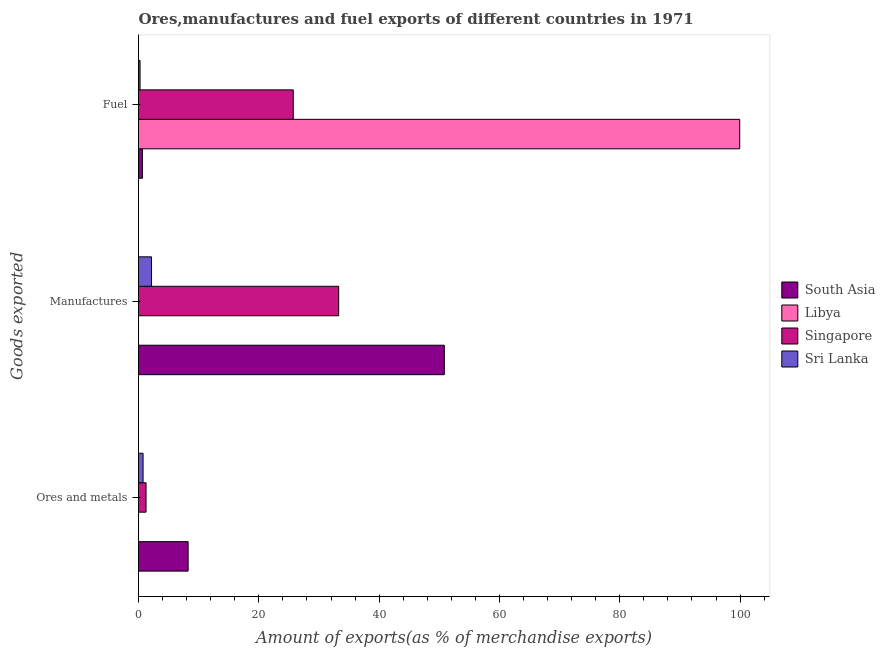What is the label of the 3rd group of bars from the top?
Ensure brevity in your answer.  Ores and metals. What is the percentage of fuel exports in Sri Lanka?
Offer a very short reply. 0.26. Across all countries, what is the maximum percentage of manufactures exports?
Offer a terse response. 50.84. Across all countries, what is the minimum percentage of manufactures exports?
Your response must be concise. 7.47831394155619e-6. In which country was the percentage of fuel exports minimum?
Keep it short and to the point. Sri Lanka. What is the total percentage of ores and metals exports in the graph?
Offer a terse response. 10.27. What is the difference between the percentage of manufactures exports in Libya and that in Singapore?
Offer a very short reply. -33.27. What is the difference between the percentage of ores and metals exports in Singapore and the percentage of fuel exports in Sri Lanka?
Give a very brief answer. 1. What is the average percentage of fuel exports per country?
Your answer should be compact. 31.64. What is the difference between the percentage of ores and metals exports and percentage of fuel exports in Libya?
Your response must be concise. -99.94. What is the ratio of the percentage of fuel exports in Singapore to that in South Asia?
Offer a very short reply. 39.73. What is the difference between the highest and the second highest percentage of manufactures exports?
Your response must be concise. 17.56. What is the difference between the highest and the lowest percentage of fuel exports?
Provide a succinct answer. 99.69. In how many countries, is the percentage of fuel exports greater than the average percentage of fuel exports taken over all countries?
Provide a short and direct response. 1. Is the sum of the percentage of ores and metals exports in South Asia and Sri Lanka greater than the maximum percentage of manufactures exports across all countries?
Offer a terse response. No. What does the 1st bar from the top in Fuel represents?
Your answer should be compact. Sri Lanka. Is it the case that in every country, the sum of the percentage of ores and metals exports and percentage of manufactures exports is greater than the percentage of fuel exports?
Provide a short and direct response. No. Are the values on the major ticks of X-axis written in scientific E-notation?
Make the answer very short. No. Does the graph contain grids?
Ensure brevity in your answer.  No. How many legend labels are there?
Your answer should be very brief. 4. How are the legend labels stacked?
Keep it short and to the point. Vertical. What is the title of the graph?
Your answer should be very brief. Ores,manufactures and fuel exports of different countries in 1971. What is the label or title of the X-axis?
Your response must be concise. Amount of exports(as % of merchandise exports). What is the label or title of the Y-axis?
Make the answer very short. Goods exported. What is the Amount of exports(as % of merchandise exports) in South Asia in Ores and metals?
Give a very brief answer. 8.25. What is the Amount of exports(as % of merchandise exports) of Libya in Ores and metals?
Give a very brief answer. 0. What is the Amount of exports(as % of merchandise exports) of Singapore in Ores and metals?
Make the answer very short. 1.25. What is the Amount of exports(as % of merchandise exports) of Sri Lanka in Ores and metals?
Offer a very short reply. 0.76. What is the Amount of exports(as % of merchandise exports) in South Asia in Manufactures?
Offer a very short reply. 50.84. What is the Amount of exports(as % of merchandise exports) of Libya in Manufactures?
Your response must be concise. 7.47831394155619e-6. What is the Amount of exports(as % of merchandise exports) in Singapore in Manufactures?
Provide a succinct answer. 33.27. What is the Amount of exports(as % of merchandise exports) of Sri Lanka in Manufactures?
Provide a succinct answer. 2.16. What is the Amount of exports(as % of merchandise exports) in South Asia in Fuel?
Your answer should be very brief. 0.65. What is the Amount of exports(as % of merchandise exports) in Libya in Fuel?
Provide a succinct answer. 99.95. What is the Amount of exports(as % of merchandise exports) of Singapore in Fuel?
Provide a succinct answer. 25.72. What is the Amount of exports(as % of merchandise exports) in Sri Lanka in Fuel?
Your answer should be very brief. 0.26. Across all Goods exported, what is the maximum Amount of exports(as % of merchandise exports) of South Asia?
Provide a succinct answer. 50.84. Across all Goods exported, what is the maximum Amount of exports(as % of merchandise exports) of Libya?
Your response must be concise. 99.95. Across all Goods exported, what is the maximum Amount of exports(as % of merchandise exports) in Singapore?
Give a very brief answer. 33.27. Across all Goods exported, what is the maximum Amount of exports(as % of merchandise exports) of Sri Lanka?
Make the answer very short. 2.16. Across all Goods exported, what is the minimum Amount of exports(as % of merchandise exports) of South Asia?
Provide a short and direct response. 0.65. Across all Goods exported, what is the minimum Amount of exports(as % of merchandise exports) in Libya?
Ensure brevity in your answer.  7.47831394155619e-6. Across all Goods exported, what is the minimum Amount of exports(as % of merchandise exports) of Singapore?
Make the answer very short. 1.25. Across all Goods exported, what is the minimum Amount of exports(as % of merchandise exports) in Sri Lanka?
Provide a succinct answer. 0.26. What is the total Amount of exports(as % of merchandise exports) in South Asia in the graph?
Offer a very short reply. 59.73. What is the total Amount of exports(as % of merchandise exports) of Libya in the graph?
Your answer should be compact. 99.95. What is the total Amount of exports(as % of merchandise exports) in Singapore in the graph?
Offer a terse response. 60.25. What is the total Amount of exports(as % of merchandise exports) of Sri Lanka in the graph?
Your response must be concise. 3.18. What is the difference between the Amount of exports(as % of merchandise exports) of South Asia in Ores and metals and that in Manufactures?
Make the answer very short. -42.59. What is the difference between the Amount of exports(as % of merchandise exports) of Libya in Ores and metals and that in Manufactures?
Offer a very short reply. 0. What is the difference between the Amount of exports(as % of merchandise exports) in Singapore in Ores and metals and that in Manufactures?
Ensure brevity in your answer.  -32.02. What is the difference between the Amount of exports(as % of merchandise exports) of Sri Lanka in Ores and metals and that in Manufactures?
Make the answer very short. -1.4. What is the difference between the Amount of exports(as % of merchandise exports) of South Asia in Ores and metals and that in Fuel?
Your answer should be very brief. 7.6. What is the difference between the Amount of exports(as % of merchandise exports) of Libya in Ores and metals and that in Fuel?
Make the answer very short. -99.94. What is the difference between the Amount of exports(as % of merchandise exports) of Singapore in Ores and metals and that in Fuel?
Provide a succinct answer. -24.47. What is the difference between the Amount of exports(as % of merchandise exports) of Sri Lanka in Ores and metals and that in Fuel?
Provide a succinct answer. 0.51. What is the difference between the Amount of exports(as % of merchandise exports) of South Asia in Manufactures and that in Fuel?
Make the answer very short. 50.19. What is the difference between the Amount of exports(as % of merchandise exports) in Libya in Manufactures and that in Fuel?
Your answer should be very brief. -99.95. What is the difference between the Amount of exports(as % of merchandise exports) of Singapore in Manufactures and that in Fuel?
Give a very brief answer. 7.55. What is the difference between the Amount of exports(as % of merchandise exports) of Sri Lanka in Manufactures and that in Fuel?
Provide a succinct answer. 1.91. What is the difference between the Amount of exports(as % of merchandise exports) of South Asia in Ores and metals and the Amount of exports(as % of merchandise exports) of Libya in Manufactures?
Offer a very short reply. 8.25. What is the difference between the Amount of exports(as % of merchandise exports) of South Asia in Ores and metals and the Amount of exports(as % of merchandise exports) of Singapore in Manufactures?
Provide a short and direct response. -25.03. What is the difference between the Amount of exports(as % of merchandise exports) of South Asia in Ores and metals and the Amount of exports(as % of merchandise exports) of Sri Lanka in Manufactures?
Ensure brevity in your answer.  6.08. What is the difference between the Amount of exports(as % of merchandise exports) of Libya in Ores and metals and the Amount of exports(as % of merchandise exports) of Singapore in Manufactures?
Your answer should be very brief. -33.27. What is the difference between the Amount of exports(as % of merchandise exports) in Libya in Ores and metals and the Amount of exports(as % of merchandise exports) in Sri Lanka in Manufactures?
Offer a terse response. -2.16. What is the difference between the Amount of exports(as % of merchandise exports) in Singapore in Ores and metals and the Amount of exports(as % of merchandise exports) in Sri Lanka in Manufactures?
Your answer should be compact. -0.91. What is the difference between the Amount of exports(as % of merchandise exports) in South Asia in Ores and metals and the Amount of exports(as % of merchandise exports) in Libya in Fuel?
Provide a short and direct response. -91.7. What is the difference between the Amount of exports(as % of merchandise exports) of South Asia in Ores and metals and the Amount of exports(as % of merchandise exports) of Singapore in Fuel?
Keep it short and to the point. -17.48. What is the difference between the Amount of exports(as % of merchandise exports) in South Asia in Ores and metals and the Amount of exports(as % of merchandise exports) in Sri Lanka in Fuel?
Your response must be concise. 7.99. What is the difference between the Amount of exports(as % of merchandise exports) of Libya in Ores and metals and the Amount of exports(as % of merchandise exports) of Singapore in Fuel?
Provide a short and direct response. -25.72. What is the difference between the Amount of exports(as % of merchandise exports) in Libya in Ores and metals and the Amount of exports(as % of merchandise exports) in Sri Lanka in Fuel?
Make the answer very short. -0.25. What is the difference between the Amount of exports(as % of merchandise exports) in Singapore in Ores and metals and the Amount of exports(as % of merchandise exports) in Sri Lanka in Fuel?
Give a very brief answer. 1. What is the difference between the Amount of exports(as % of merchandise exports) of South Asia in Manufactures and the Amount of exports(as % of merchandise exports) of Libya in Fuel?
Keep it short and to the point. -49.11. What is the difference between the Amount of exports(as % of merchandise exports) of South Asia in Manufactures and the Amount of exports(as % of merchandise exports) of Singapore in Fuel?
Make the answer very short. 25.11. What is the difference between the Amount of exports(as % of merchandise exports) of South Asia in Manufactures and the Amount of exports(as % of merchandise exports) of Sri Lanka in Fuel?
Your answer should be very brief. 50.58. What is the difference between the Amount of exports(as % of merchandise exports) in Libya in Manufactures and the Amount of exports(as % of merchandise exports) in Singapore in Fuel?
Give a very brief answer. -25.72. What is the difference between the Amount of exports(as % of merchandise exports) in Libya in Manufactures and the Amount of exports(as % of merchandise exports) in Sri Lanka in Fuel?
Offer a terse response. -0.26. What is the difference between the Amount of exports(as % of merchandise exports) in Singapore in Manufactures and the Amount of exports(as % of merchandise exports) in Sri Lanka in Fuel?
Your response must be concise. 33.02. What is the average Amount of exports(as % of merchandise exports) of South Asia per Goods exported?
Your answer should be very brief. 19.91. What is the average Amount of exports(as % of merchandise exports) in Libya per Goods exported?
Make the answer very short. 33.32. What is the average Amount of exports(as % of merchandise exports) in Singapore per Goods exported?
Your answer should be very brief. 20.08. What is the average Amount of exports(as % of merchandise exports) in Sri Lanka per Goods exported?
Your answer should be very brief. 1.06. What is the difference between the Amount of exports(as % of merchandise exports) in South Asia and Amount of exports(as % of merchandise exports) in Libya in Ores and metals?
Your answer should be compact. 8.24. What is the difference between the Amount of exports(as % of merchandise exports) of South Asia and Amount of exports(as % of merchandise exports) of Singapore in Ores and metals?
Your answer should be compact. 7. What is the difference between the Amount of exports(as % of merchandise exports) in South Asia and Amount of exports(as % of merchandise exports) in Sri Lanka in Ores and metals?
Your response must be concise. 7.49. What is the difference between the Amount of exports(as % of merchandise exports) in Libya and Amount of exports(as % of merchandise exports) in Singapore in Ores and metals?
Your answer should be very brief. -1.25. What is the difference between the Amount of exports(as % of merchandise exports) in Libya and Amount of exports(as % of merchandise exports) in Sri Lanka in Ores and metals?
Offer a terse response. -0.76. What is the difference between the Amount of exports(as % of merchandise exports) of Singapore and Amount of exports(as % of merchandise exports) of Sri Lanka in Ores and metals?
Your response must be concise. 0.49. What is the difference between the Amount of exports(as % of merchandise exports) in South Asia and Amount of exports(as % of merchandise exports) in Libya in Manufactures?
Your answer should be compact. 50.84. What is the difference between the Amount of exports(as % of merchandise exports) of South Asia and Amount of exports(as % of merchandise exports) of Singapore in Manufactures?
Your response must be concise. 17.56. What is the difference between the Amount of exports(as % of merchandise exports) of South Asia and Amount of exports(as % of merchandise exports) of Sri Lanka in Manufactures?
Keep it short and to the point. 48.67. What is the difference between the Amount of exports(as % of merchandise exports) in Libya and Amount of exports(as % of merchandise exports) in Singapore in Manufactures?
Provide a succinct answer. -33.27. What is the difference between the Amount of exports(as % of merchandise exports) in Libya and Amount of exports(as % of merchandise exports) in Sri Lanka in Manufactures?
Give a very brief answer. -2.16. What is the difference between the Amount of exports(as % of merchandise exports) in Singapore and Amount of exports(as % of merchandise exports) in Sri Lanka in Manufactures?
Offer a very short reply. 31.11. What is the difference between the Amount of exports(as % of merchandise exports) in South Asia and Amount of exports(as % of merchandise exports) in Libya in Fuel?
Keep it short and to the point. -99.3. What is the difference between the Amount of exports(as % of merchandise exports) of South Asia and Amount of exports(as % of merchandise exports) of Singapore in Fuel?
Give a very brief answer. -25.08. What is the difference between the Amount of exports(as % of merchandise exports) in South Asia and Amount of exports(as % of merchandise exports) in Sri Lanka in Fuel?
Provide a succinct answer. 0.39. What is the difference between the Amount of exports(as % of merchandise exports) in Libya and Amount of exports(as % of merchandise exports) in Singapore in Fuel?
Provide a succinct answer. 74.22. What is the difference between the Amount of exports(as % of merchandise exports) of Libya and Amount of exports(as % of merchandise exports) of Sri Lanka in Fuel?
Your response must be concise. 99.69. What is the difference between the Amount of exports(as % of merchandise exports) in Singapore and Amount of exports(as % of merchandise exports) in Sri Lanka in Fuel?
Your answer should be very brief. 25.47. What is the ratio of the Amount of exports(as % of merchandise exports) in South Asia in Ores and metals to that in Manufactures?
Provide a short and direct response. 0.16. What is the ratio of the Amount of exports(as % of merchandise exports) in Libya in Ores and metals to that in Manufactures?
Offer a terse response. 565.87. What is the ratio of the Amount of exports(as % of merchandise exports) of Singapore in Ores and metals to that in Manufactures?
Provide a short and direct response. 0.04. What is the ratio of the Amount of exports(as % of merchandise exports) of Sri Lanka in Ores and metals to that in Manufactures?
Provide a short and direct response. 0.35. What is the ratio of the Amount of exports(as % of merchandise exports) in South Asia in Ores and metals to that in Fuel?
Your answer should be very brief. 12.74. What is the ratio of the Amount of exports(as % of merchandise exports) of Libya in Ores and metals to that in Fuel?
Offer a very short reply. 0. What is the ratio of the Amount of exports(as % of merchandise exports) in Singapore in Ores and metals to that in Fuel?
Provide a short and direct response. 0.05. What is the ratio of the Amount of exports(as % of merchandise exports) of Sri Lanka in Ores and metals to that in Fuel?
Ensure brevity in your answer.  2.98. What is the ratio of the Amount of exports(as % of merchandise exports) in South Asia in Manufactures to that in Fuel?
Your answer should be compact. 78.53. What is the ratio of the Amount of exports(as % of merchandise exports) in Singapore in Manufactures to that in Fuel?
Ensure brevity in your answer.  1.29. What is the ratio of the Amount of exports(as % of merchandise exports) in Sri Lanka in Manufactures to that in Fuel?
Keep it short and to the point. 8.48. What is the difference between the highest and the second highest Amount of exports(as % of merchandise exports) of South Asia?
Give a very brief answer. 42.59. What is the difference between the highest and the second highest Amount of exports(as % of merchandise exports) in Libya?
Keep it short and to the point. 99.94. What is the difference between the highest and the second highest Amount of exports(as % of merchandise exports) of Singapore?
Ensure brevity in your answer.  7.55. What is the difference between the highest and the second highest Amount of exports(as % of merchandise exports) of Sri Lanka?
Your answer should be very brief. 1.4. What is the difference between the highest and the lowest Amount of exports(as % of merchandise exports) of South Asia?
Provide a succinct answer. 50.19. What is the difference between the highest and the lowest Amount of exports(as % of merchandise exports) in Libya?
Provide a succinct answer. 99.95. What is the difference between the highest and the lowest Amount of exports(as % of merchandise exports) of Singapore?
Offer a very short reply. 32.02. What is the difference between the highest and the lowest Amount of exports(as % of merchandise exports) in Sri Lanka?
Ensure brevity in your answer.  1.91. 